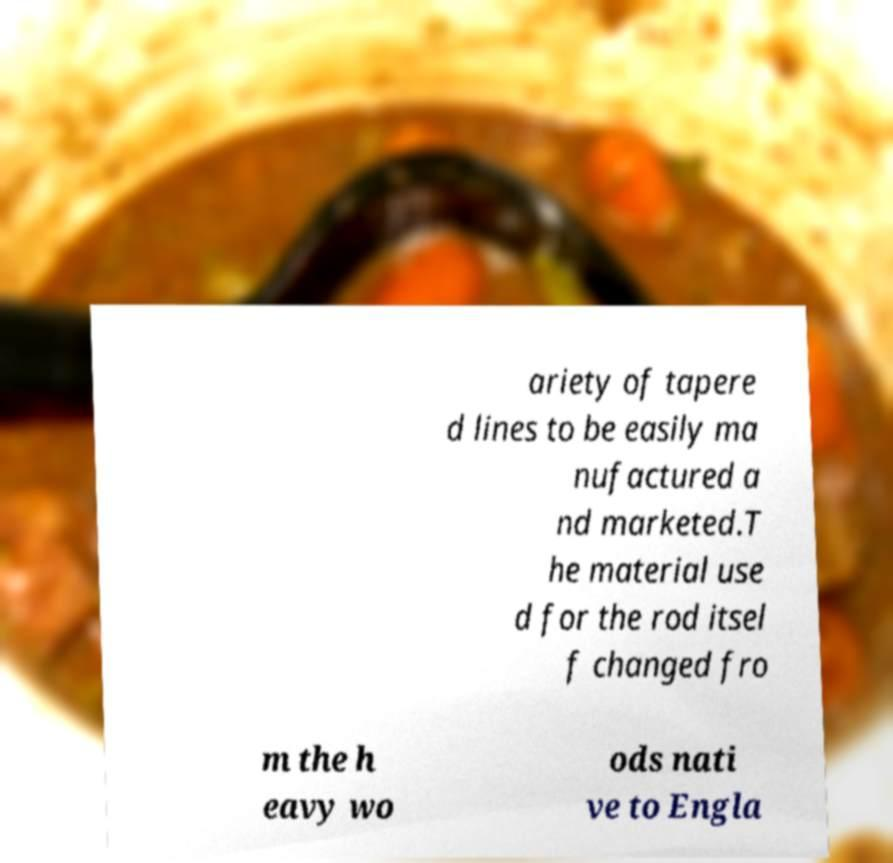There's text embedded in this image that I need extracted. Can you transcribe it verbatim? ariety of tapere d lines to be easily ma nufactured a nd marketed.T he material use d for the rod itsel f changed fro m the h eavy wo ods nati ve to Engla 